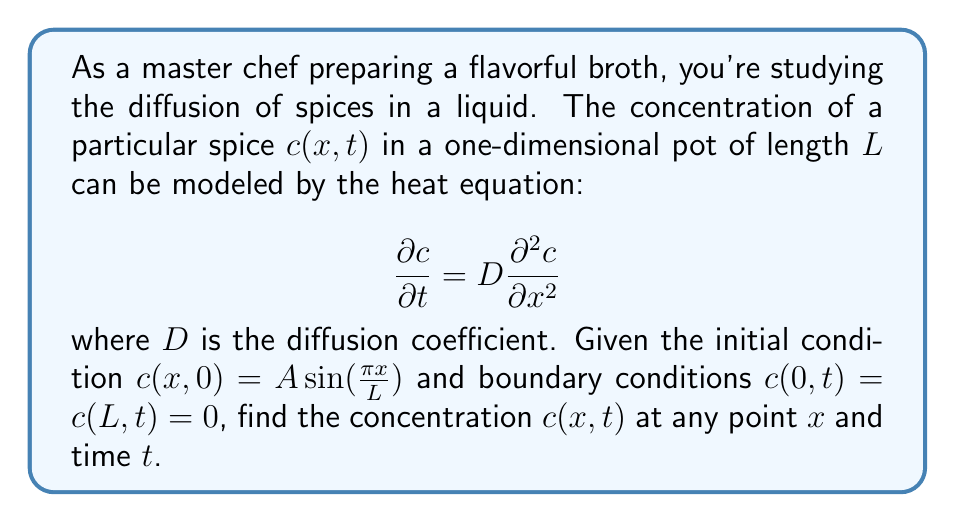What is the answer to this math problem? To solve this problem, we'll follow these steps:

1) The general solution to the heat equation with the given boundary conditions is:

   $$c(x,t) = \sum_{n=1}^{\infty} B_n \sin(\frac{n\pi x}{L}) e^{-D(\frac{n\pi}{L})^2 t}$$

2) We need to match this with the initial condition to find $B_n$. At $t=0$:

   $$A \sin(\frac{\pi x}{L}) = \sum_{n=1}^{\infty} B_n \sin(\frac{n\pi x}{L})$$

3) This implies that $B_1 = A$ and $B_n = 0$ for $n > 1$.

4) Therefore, the solution is:

   $$c(x,t) = A \sin(\frac{\pi x}{L}) e^{-D(\frac{\pi}{L})^2 t}$$

5) This equation describes how the concentration of the spice changes over time and position in the pot. The exponential term shows how the concentration decays over time due to diffusion.
Answer: $c(x,t) = A \sin(\frac{\pi x}{L}) e^{-D(\frac{\pi}{L})^2 t}$ 